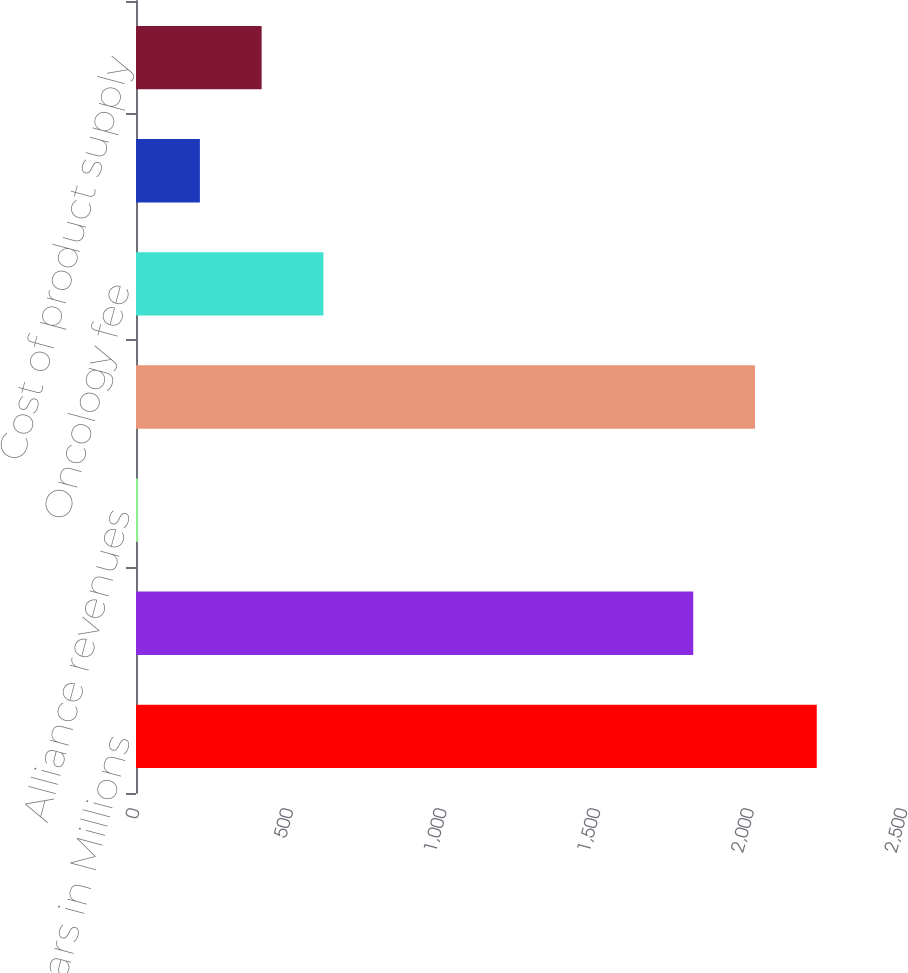<chart> <loc_0><loc_0><loc_500><loc_500><bar_chart><fcel>Dollars in Millions<fcel>Net product sales<fcel>Alliance revenues<fcel>Total Revenues<fcel>Oncology fee<fcel>Royalties<fcel>Cost of product supply<nl><fcel>2216<fcel>1814<fcel>7<fcel>2015<fcel>610<fcel>208<fcel>409<nl></chart> 